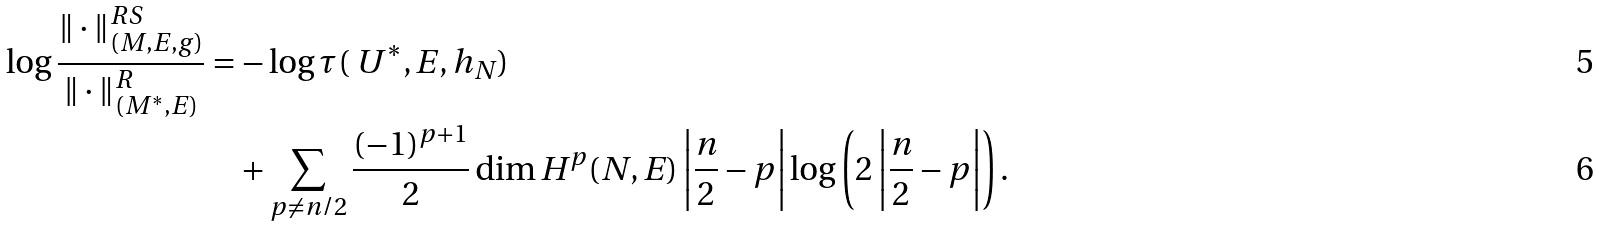Convert formula to latex. <formula><loc_0><loc_0><loc_500><loc_500>\log \frac { \| \cdot \| ^ { R S } _ { ( M , E , g ) } } { \| \cdot \| ^ { R } _ { ( M ^ { * } , E ) } } = & - \log \tau ( \ U ^ { * } , E , h _ { N } ) \\ & + \sum _ { p \neq n / 2 } \frac { ( - 1 ) ^ { p + 1 } } { 2 } \dim H ^ { p } ( N , E ) \left | \frac { n } { 2 } - p \right | \log \left ( 2 \left | \frac { n } { 2 } - p \right | \right ) .</formula> 